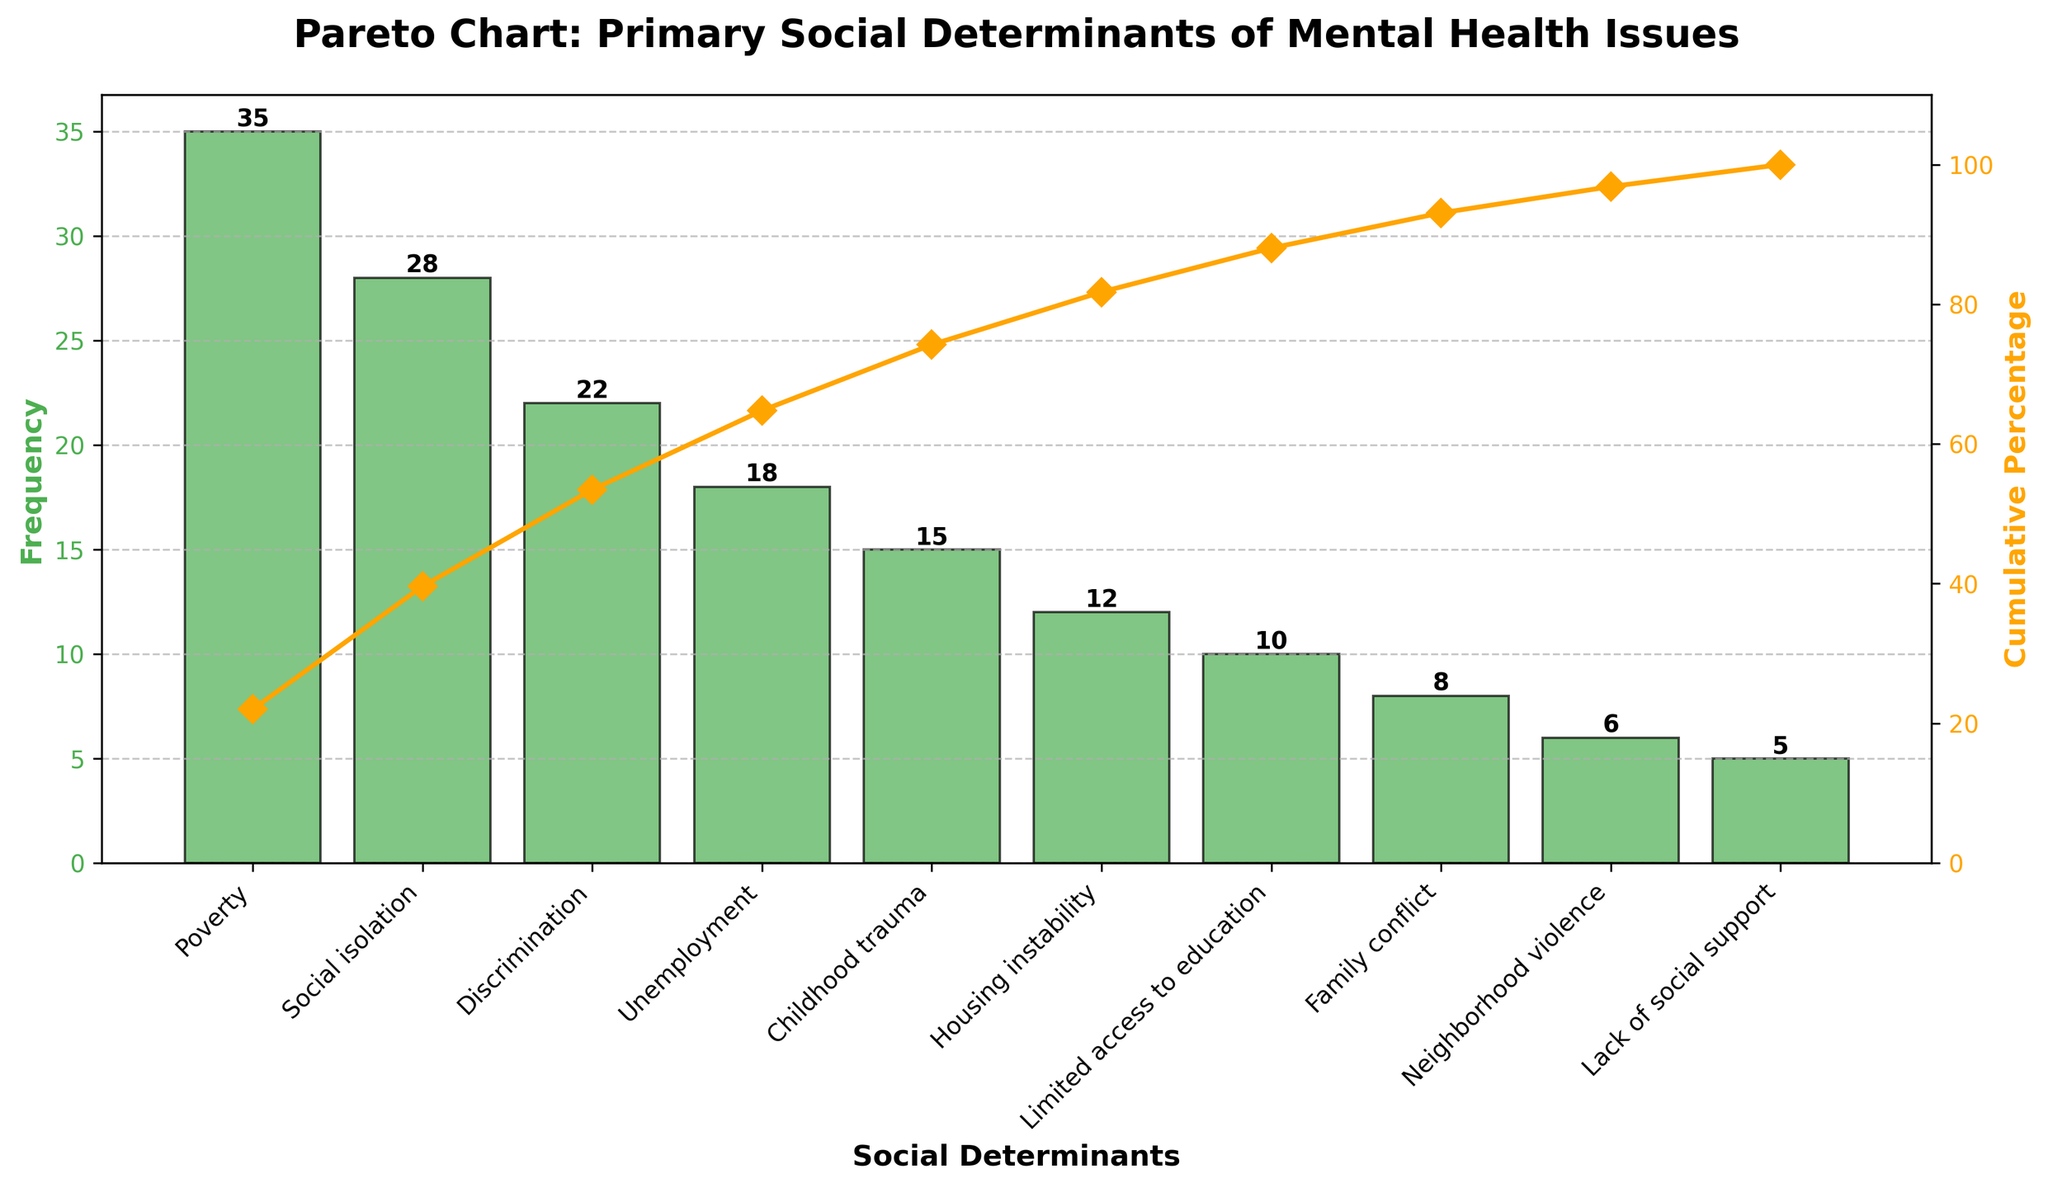How many social determinants are listed in the figure? Count the number of distinct categories on the x-axis.
Answer: 10 What is the title of the figure? Read the title at the top of the chart.
Answer: Pareto Chart: Primary Social Determinants of Mental Health Issues Which social determinant has the highest frequency? Identify the bar with the tallest height, which is labeled.
Answer: Poverty What is the frequency of discrimination? Find the height of the bar labeled "Discrimination."
Answer: 22 What is the cumulative percentage for unemployment? Note the position of the dot on the cumulative percentage line at "Unemployment."
Answer: 70% What is the difference in frequency between social isolation and childhood trauma? Subtract the frequency of "Childhood trauma" from "Social isolation" (28 - 15).
Answer: 13 Which factor has a higher frequency: neighborhood violence or family conflict? Compare the heights of the bars labeled "Neighborhood violence" and "Family conflict."
Answer: Family conflict What is the sum of frequencies for the top three social determinants? Add the frequencies of "Poverty," "Social isolation," and “Discrimination” (35 + 28 + 22).
Answer: 85 How many determinants have a frequency of less than 10? Count the bars whose heights are below the 10 mark.
Answer: 3 At what cumulative percentage do the top five social determinants of mental health issues reach? Look at the cumulative percentage dot at the "Housing instability" label.
Answer: 82% 